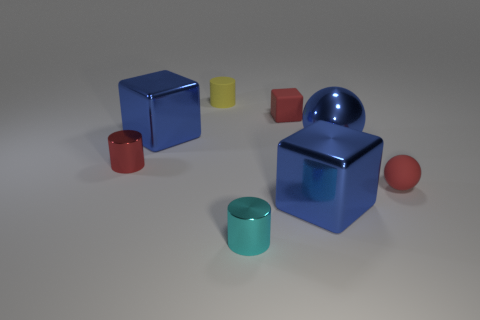Add 1 tiny green objects. How many objects exist? 9 Subtract all cylinders. How many objects are left? 5 Add 5 tiny cyan metallic cylinders. How many tiny cyan metallic cylinders exist? 6 Subtract 1 blue balls. How many objects are left? 7 Subtract all big metallic balls. Subtract all red matte balls. How many objects are left? 6 Add 4 cylinders. How many cylinders are left? 7 